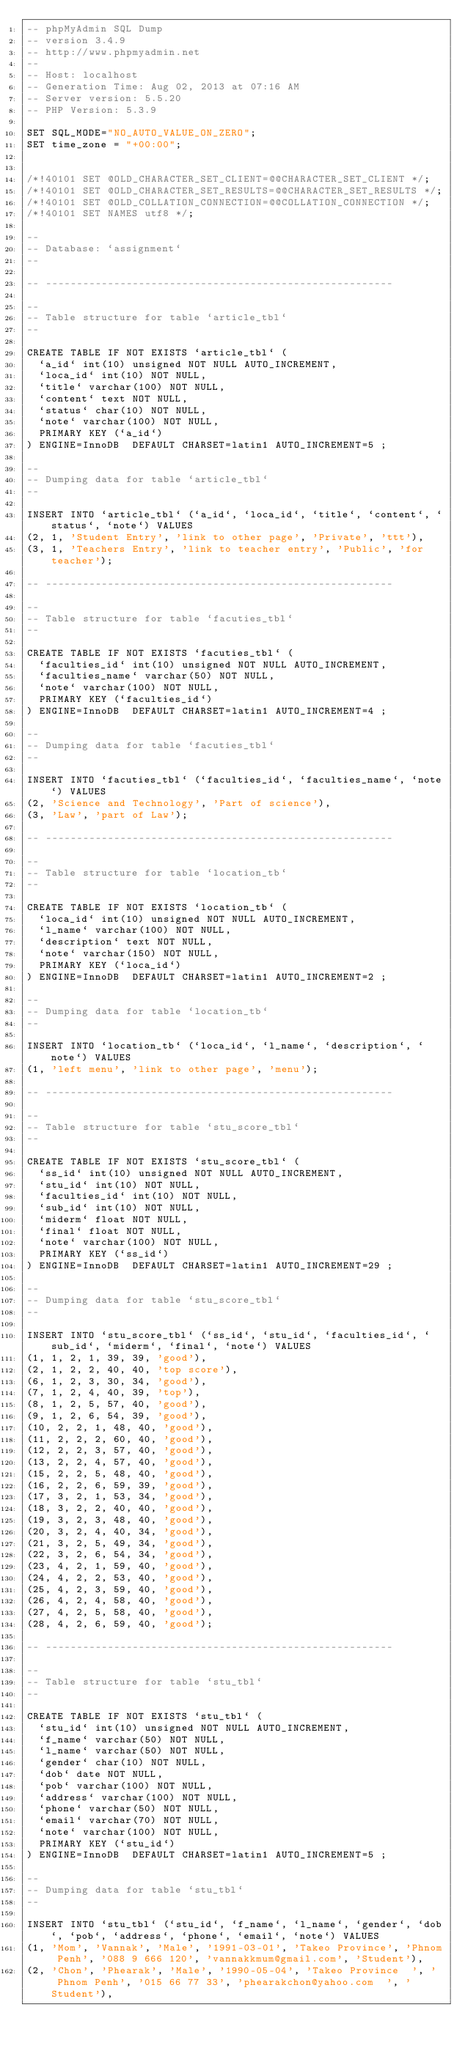<code> <loc_0><loc_0><loc_500><loc_500><_SQL_>-- phpMyAdmin SQL Dump
-- version 3.4.9
-- http://www.phpmyadmin.net
--
-- Host: localhost
-- Generation Time: Aug 02, 2013 at 07:16 AM
-- Server version: 5.5.20
-- PHP Version: 5.3.9

SET SQL_MODE="NO_AUTO_VALUE_ON_ZERO";
SET time_zone = "+00:00";


/*!40101 SET @OLD_CHARACTER_SET_CLIENT=@@CHARACTER_SET_CLIENT */;
/*!40101 SET @OLD_CHARACTER_SET_RESULTS=@@CHARACTER_SET_RESULTS */;
/*!40101 SET @OLD_COLLATION_CONNECTION=@@COLLATION_CONNECTION */;
/*!40101 SET NAMES utf8 */;

--
-- Database: `assignment`
--

-- --------------------------------------------------------

--
-- Table structure for table `article_tbl`
--

CREATE TABLE IF NOT EXISTS `article_tbl` (
  `a_id` int(10) unsigned NOT NULL AUTO_INCREMENT,
  `loca_id` int(10) NOT NULL,
  `title` varchar(100) NOT NULL,
  `content` text NOT NULL,
  `status` char(10) NOT NULL,
  `note` varchar(100) NOT NULL,
  PRIMARY KEY (`a_id`)
) ENGINE=InnoDB  DEFAULT CHARSET=latin1 AUTO_INCREMENT=5 ;

--
-- Dumping data for table `article_tbl`
--

INSERT INTO `article_tbl` (`a_id`, `loca_id`, `title`, `content`, `status`, `note`) VALUES
(2, 1, 'Student Entry', 'link to other page', 'Private', 'ttt'),
(3, 1, 'Teachers Entry', 'link to teacher entry', 'Public', 'for teacher');

-- --------------------------------------------------------

--
-- Table structure for table `facuties_tbl`
--

CREATE TABLE IF NOT EXISTS `facuties_tbl` (
  `faculties_id` int(10) unsigned NOT NULL AUTO_INCREMENT,
  `faculties_name` varchar(50) NOT NULL,
  `note` varchar(100) NOT NULL,
  PRIMARY KEY (`faculties_id`)
) ENGINE=InnoDB  DEFAULT CHARSET=latin1 AUTO_INCREMENT=4 ;

--
-- Dumping data for table `facuties_tbl`
--

INSERT INTO `facuties_tbl` (`faculties_id`, `faculties_name`, `note`) VALUES
(2, 'Science and Technology', 'Part of science'),
(3, 'Law', 'part of Law');

-- --------------------------------------------------------

--
-- Table structure for table `location_tb`
--

CREATE TABLE IF NOT EXISTS `location_tb` (
  `loca_id` int(10) unsigned NOT NULL AUTO_INCREMENT,
  `l_name` varchar(100) NOT NULL,
  `description` text NOT NULL,
  `note` varchar(150) NOT NULL,
  PRIMARY KEY (`loca_id`)
) ENGINE=InnoDB  DEFAULT CHARSET=latin1 AUTO_INCREMENT=2 ;

--
-- Dumping data for table `location_tb`
--

INSERT INTO `location_tb` (`loca_id`, `l_name`, `description`, `note`) VALUES
(1, 'left menu', 'link to other page', 'menu');

-- --------------------------------------------------------

--
-- Table structure for table `stu_score_tbl`
--

CREATE TABLE IF NOT EXISTS `stu_score_tbl` (
  `ss_id` int(10) unsigned NOT NULL AUTO_INCREMENT,
  `stu_id` int(10) NOT NULL,
  `faculties_id` int(10) NOT NULL,
  `sub_id` int(10) NOT NULL,
  `miderm` float NOT NULL,
  `final` float NOT NULL,
  `note` varchar(100) NOT NULL,
  PRIMARY KEY (`ss_id`)
) ENGINE=InnoDB  DEFAULT CHARSET=latin1 AUTO_INCREMENT=29 ;

--
-- Dumping data for table `stu_score_tbl`
--

INSERT INTO `stu_score_tbl` (`ss_id`, `stu_id`, `faculties_id`, `sub_id`, `miderm`, `final`, `note`) VALUES
(1, 1, 2, 1, 39, 39, 'good'),
(2, 1, 2, 2, 40, 40, 'top score'),
(6, 1, 2, 3, 30, 34, 'good'),
(7, 1, 2, 4, 40, 39, 'top'),
(8, 1, 2, 5, 57, 40, 'good'),
(9, 1, 2, 6, 54, 39, 'good'),
(10, 2, 2, 1, 48, 40, 'good'),
(11, 2, 2, 2, 60, 40, 'good'),
(12, 2, 2, 3, 57, 40, 'good'),
(13, 2, 2, 4, 57, 40, 'good'),
(15, 2, 2, 5, 48, 40, 'good'),
(16, 2, 2, 6, 59, 39, 'good'),
(17, 3, 2, 1, 53, 34, 'good'),
(18, 3, 2, 2, 40, 40, 'good'),
(19, 3, 2, 3, 48, 40, 'good'),
(20, 3, 2, 4, 40, 34, 'good'),
(21, 3, 2, 5, 49, 34, 'good'),
(22, 3, 2, 6, 54, 34, 'good'),
(23, 4, 2, 1, 59, 40, 'good'),
(24, 4, 2, 2, 53, 40, 'good'),
(25, 4, 2, 3, 59, 40, 'good'),
(26, 4, 2, 4, 58, 40, 'good'),
(27, 4, 2, 5, 58, 40, 'good'),
(28, 4, 2, 6, 59, 40, 'good');

-- --------------------------------------------------------

--
-- Table structure for table `stu_tbl`
--

CREATE TABLE IF NOT EXISTS `stu_tbl` (
  `stu_id` int(10) unsigned NOT NULL AUTO_INCREMENT,
  `f_name` varchar(50) NOT NULL,
  `l_name` varchar(50) NOT NULL,
  `gender` char(10) NOT NULL,
  `dob` date NOT NULL,
  `pob` varchar(100) NOT NULL,
  `address` varchar(100) NOT NULL,
  `phone` varchar(50) NOT NULL,
  `email` varchar(70) NOT NULL,
  `note` varchar(100) NOT NULL,
  PRIMARY KEY (`stu_id`)
) ENGINE=InnoDB  DEFAULT CHARSET=latin1 AUTO_INCREMENT=5 ;

--
-- Dumping data for table `stu_tbl`
--

INSERT INTO `stu_tbl` (`stu_id`, `f_name`, `l_name`, `gender`, `dob`, `pob`, `address`, `phone`, `email`, `note`) VALUES
(1, 'Mom', 'Vannak', 'Male', '1991-03-01', 'Takeo Province', 'Phnom Penh', '088 9 666 120', 'vannakkmum@gmail.com', 'Student'),
(2, 'Chon', 'Phearak', 'Male', '1990-05-04', 'Takeo Province  ', '  Phnom Penh', '015 66 77 33', 'phearakchon@yahoo.com  ', 'Student'),</code> 